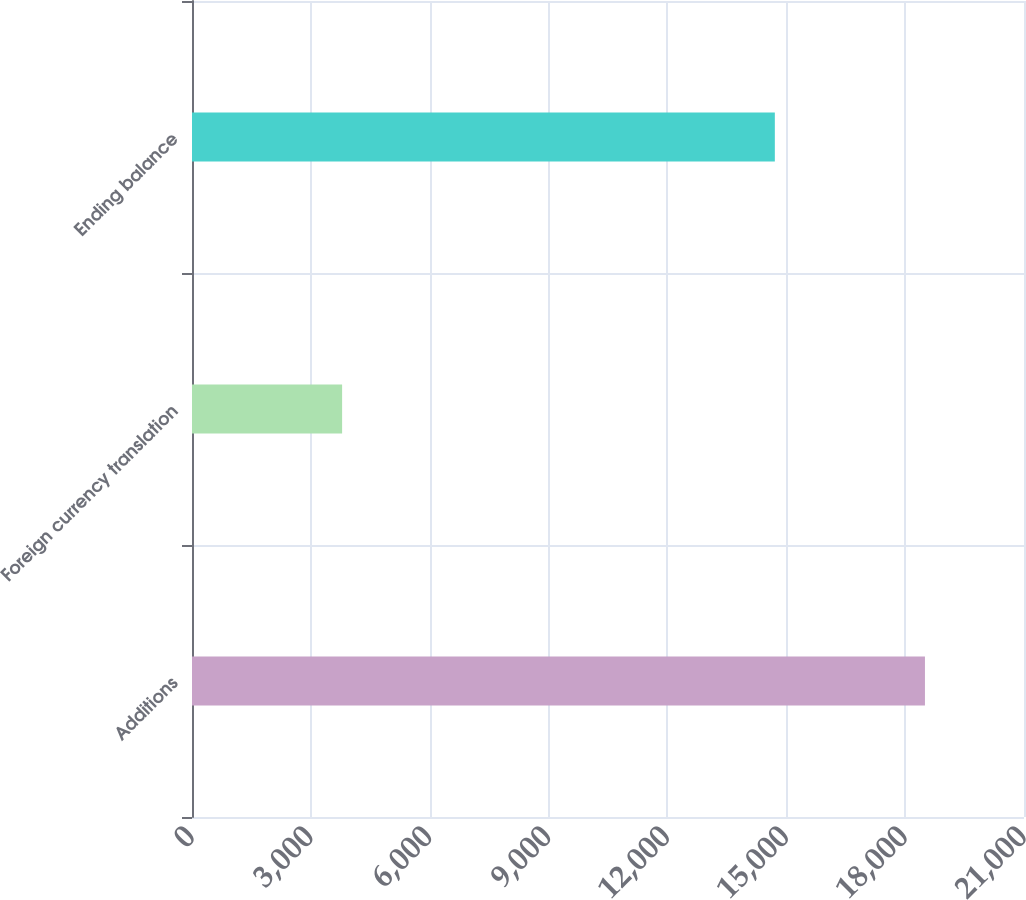Convert chart to OTSL. <chart><loc_0><loc_0><loc_500><loc_500><bar_chart><fcel>Additions<fcel>Foreign currency translation<fcel>Ending balance<nl><fcel>18500<fcel>3789<fcel>14711<nl></chart> 